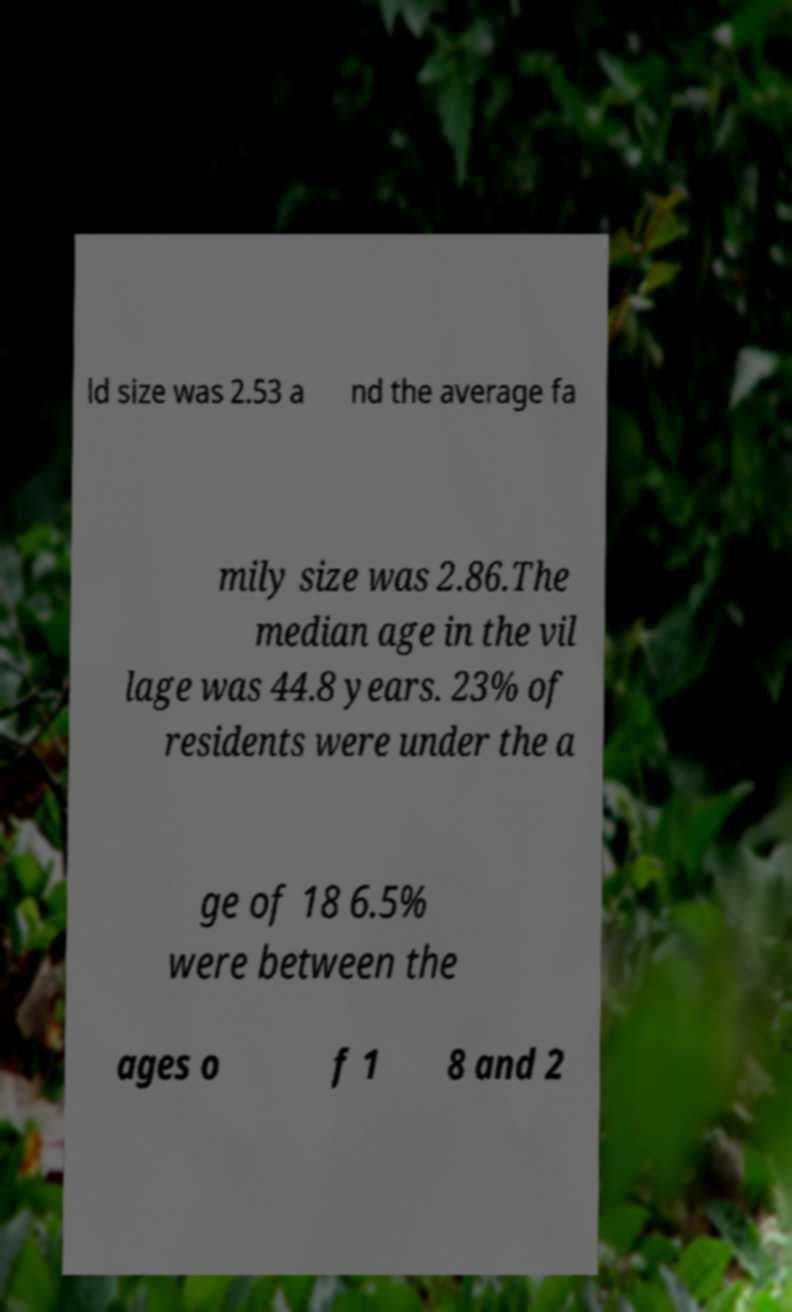Please identify and transcribe the text found in this image. ld size was 2.53 a nd the average fa mily size was 2.86.The median age in the vil lage was 44.8 years. 23% of residents were under the a ge of 18 6.5% were between the ages o f 1 8 and 2 